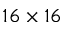<formula> <loc_0><loc_0><loc_500><loc_500>1 6 \times 1 6</formula> 